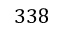<formula> <loc_0><loc_0><loc_500><loc_500>3 3 8</formula> 